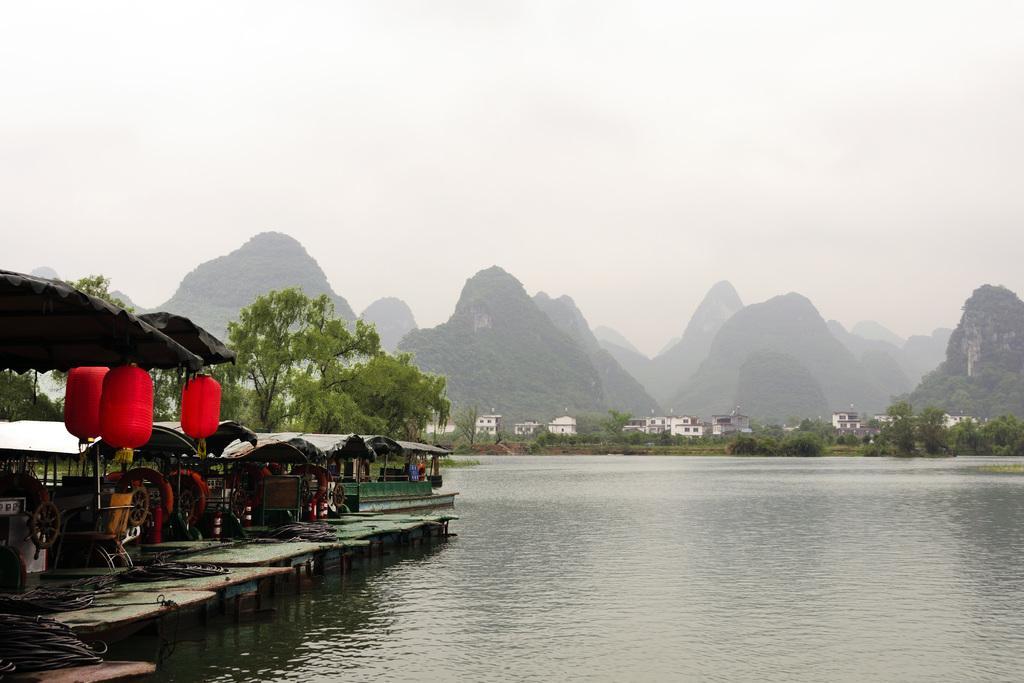In one or two sentences, can you explain what this image depicts? In this picture there are few boats in the left corner and there is water beside it and there are trees,buildings and mountains in the background. 